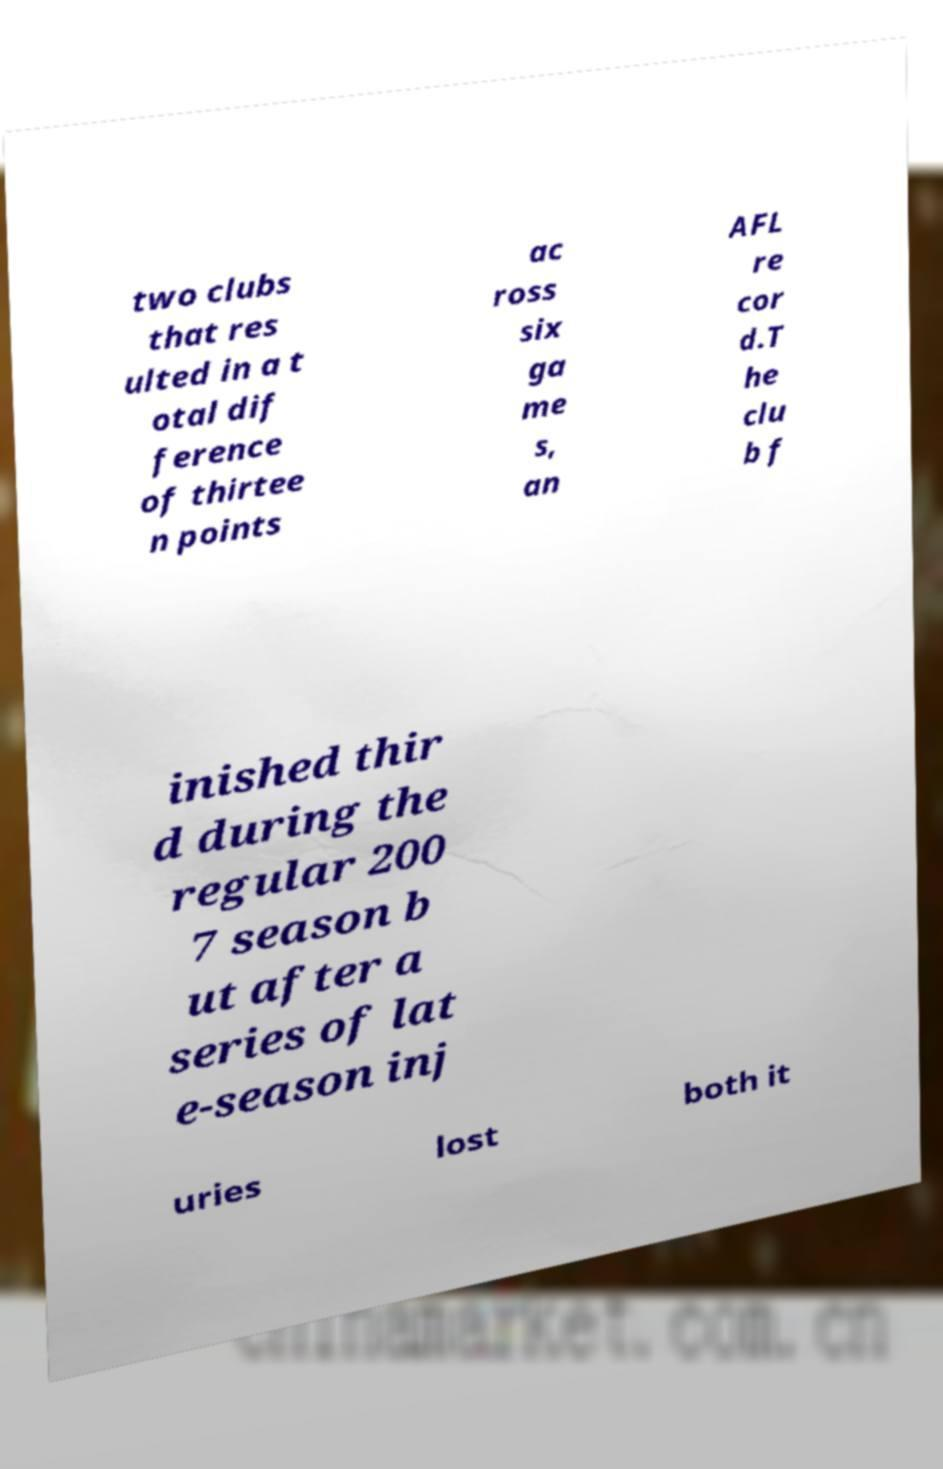Please identify and transcribe the text found in this image. two clubs that res ulted in a t otal dif ference of thirtee n points ac ross six ga me s, an AFL re cor d.T he clu b f inished thir d during the regular 200 7 season b ut after a series of lat e-season inj uries lost both it 